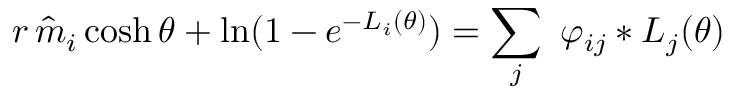<formula> <loc_0><loc_0><loc_500><loc_500>r \, \hat { m } _ { i } \cosh \theta + \ln ( 1 - e ^ { - L _ { i } ( \theta ) } ) = \sum _ { j } \, \varphi _ { i j } \ast L _ { j } ( \theta )</formula> 